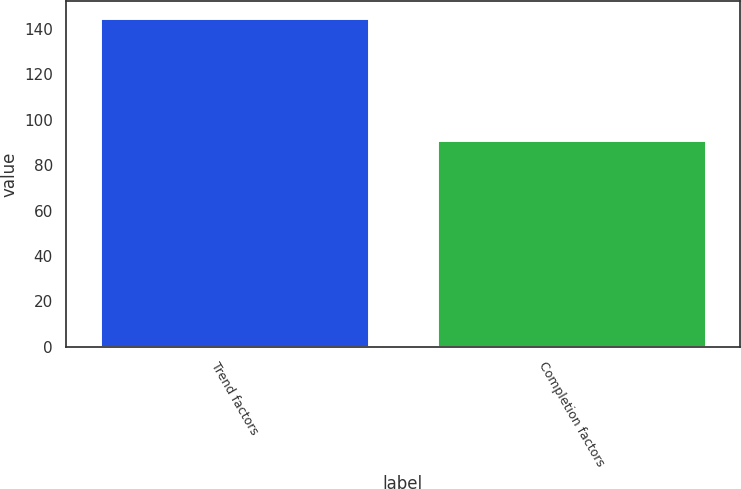Convert chart. <chart><loc_0><loc_0><loc_500><loc_500><bar_chart><fcel>Trend factors<fcel>Completion factors<nl><fcel>145<fcel>91<nl></chart> 